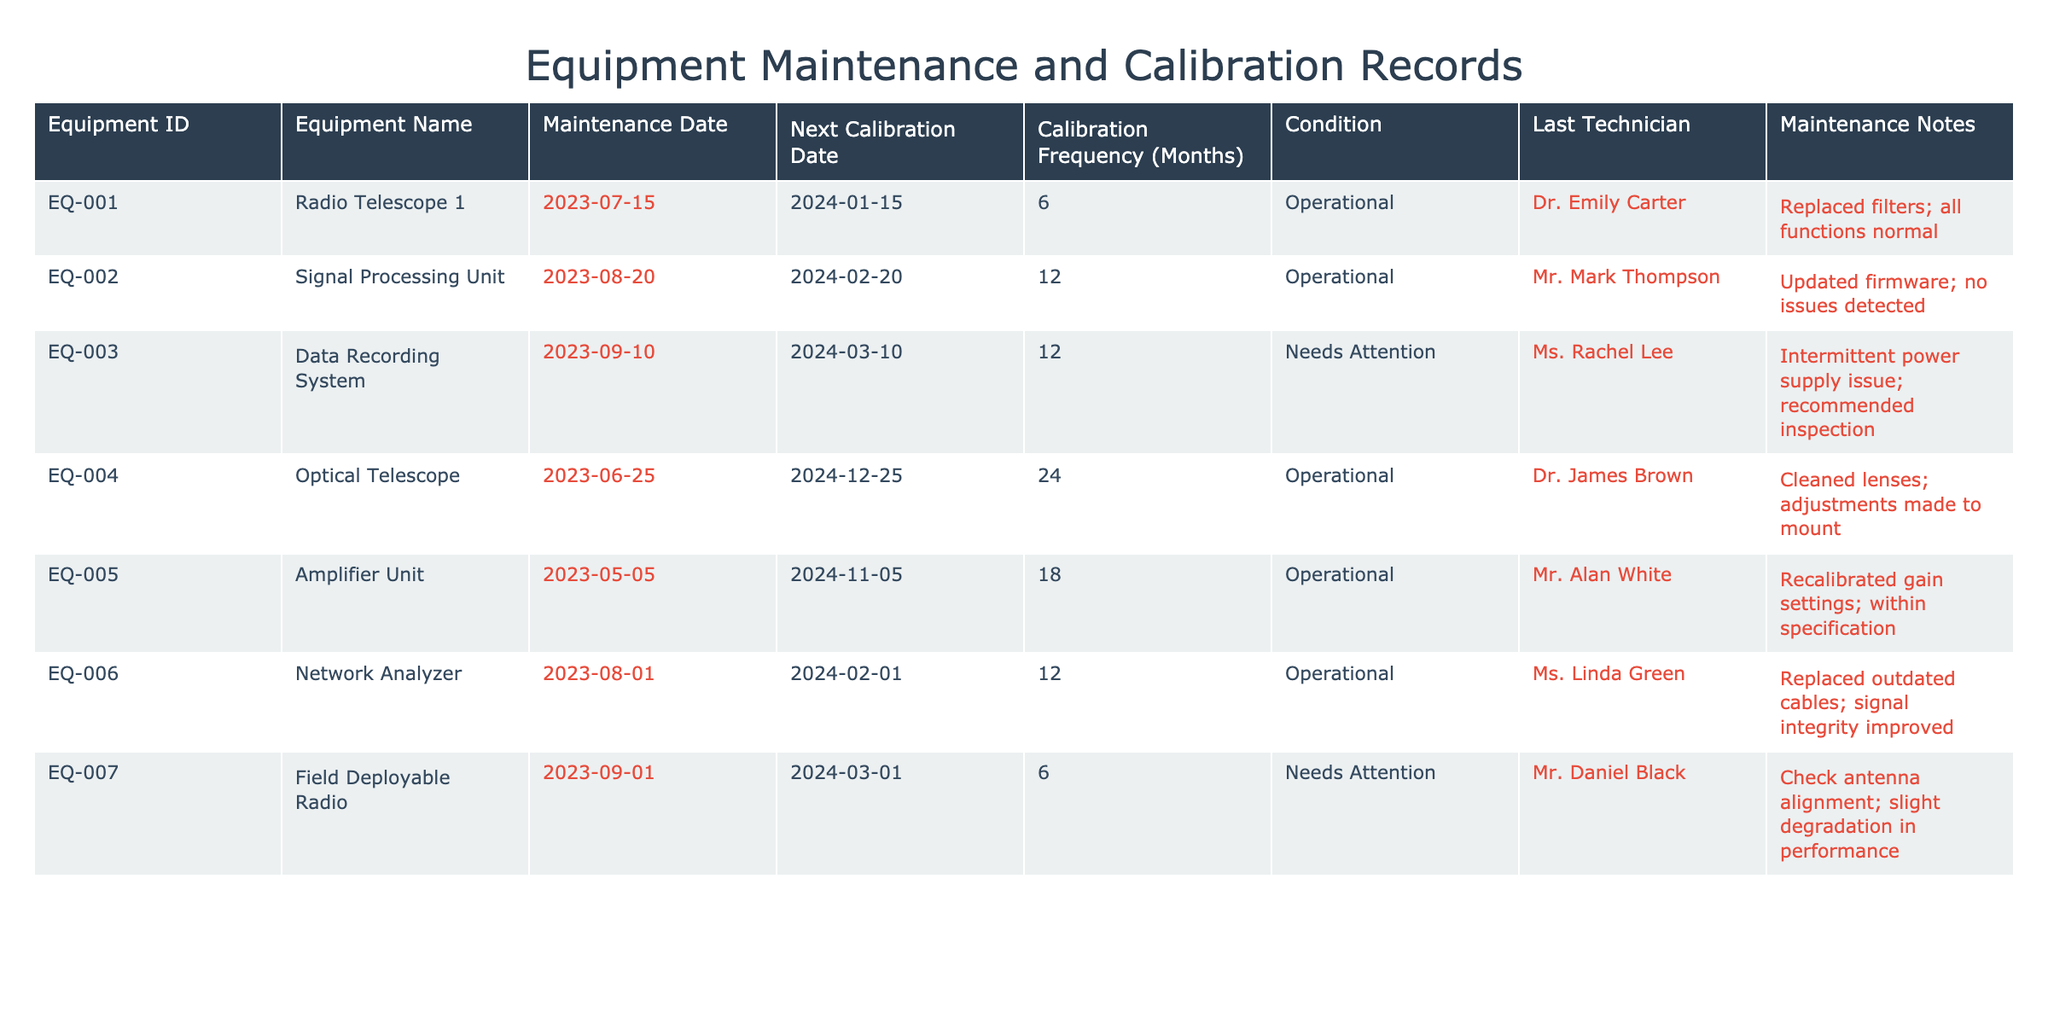What is the condition of the Data Recording System? The Data Recording System is listed under the "Condition" column, where it states "Needs Attention." This means that the equipment requires some maintenance or repair work to function properly.
Answer: Needs Attention Who was the last technician for the Radio Telescope 1? The last technician recorded for the Radio Telescope 1 is Dr. Emily Carter, as indicated in the "Last Technician" column corresponding to that equipment.
Answer: Dr. Emily Carter How many pieces of equipment are in operational condition? Three pieces of equipment are operational: Radio Telescope 1, Signal Processing Unit, and Optical Telescope as seen in the "Condition" column, where they are all marked as "Operational."
Answer: 5 What is the average calibration frequency of all equipment listed? The calibration frequencies from the table are: 6, 12, 12, 24, 18, 12, and 6 months. Summing these gives 90, and there are 7 pieces of equipment. Therefore, the average frequency is 90 / 7 = approximately 12.86 months.
Answer: 12.86 Is there any equipment with a next calibration date in the year 2024? Yes, when checking the "Next Calibration Date" column, all pieces of equipment have a date in 2024, thus confirming the statement is true.
Answer: Yes Which equipment has the shortest time until the next calibration? The Radio Telescope 1 has the next calibration date on January 15, 2024, which is the earliest date among all listed equipment. This determination is based on comparing the "Next Calibration Date" values of all equipment.
Answer: Radio Telescope 1 What maintenance notes were provided for the Field Deployable Radio? The maintenance notes for the Field Deployable Radio state "Check antenna alignment; slight degradation in performance," as shown in the corresponding column of the table.
Answer: Check antenna alignment; slight degradation in performance How many pieces of equipment need attention when considering their status? There are two pieces of equipment that need attention: Data Recording System and Field Deployable Radio. Both are indicated in the "Condition" column as "Needs Attention."
Answer: 2 How many days until the next calibration for the Amplifier Unit from today? The next calibration date for the Amplifier Unit is November 5, 2024. Counting days from today (October 17, 2023) to that date gives a total of 384 days remaining until calibration. This is reached by simple date calculation.
Answer: 384 days 